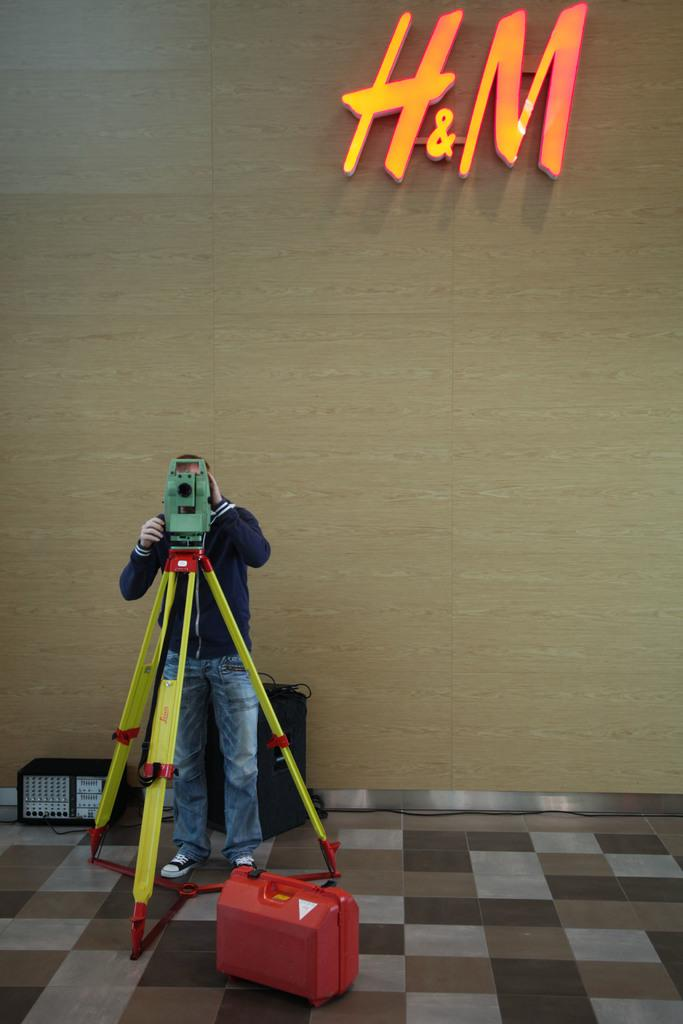What object is on the floor in the image? There is a red suitcase on the floor. What is the man in the image doing? The man is standing in the image and holding a camera with a stand. What type of items can be seen in the image besides the man and the suitcase? There are electronic devices in the image. Where is the shelf with the magic yak in the image? There is no shelf or magic yak present in the image. 